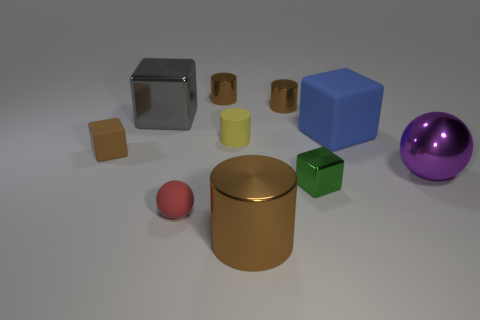What color is the large cylinder? The large cylinder in the image is a gleaming gold color, which stands out against the more subdued tones of the other objects around it. 